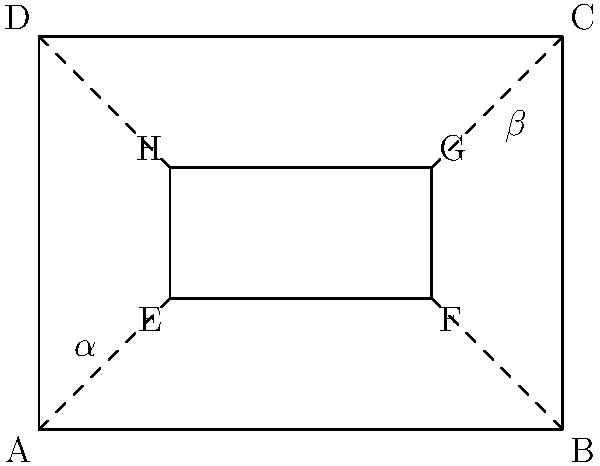In designing a stage set for your upcoming Broadway revival, you've created a rectangular backdrop (ABCD) with a smaller rectangular opening (EFGH) for a window. If angle $\alpha$ (formed by AE and AB) is congruent to angle $\beta$ (formed by CG and CB), what can you conclude about the shape EFGH in relation to ABCD? Let's approach this step-by-step:

1) In a rectangle, all interior angles are 90°. This applies to both ABCD and EFGH.

2) When a line is drawn from a corner of the larger rectangle to a corner of the smaller rectangle (like AE or CG), it creates two angles: one with the side of the larger rectangle and one with the side of the smaller rectangle.

3) We're told that angle $\alpha$ (formed by AE and AB) is congruent to angle $\beta$ (formed by CG and CB).

4) In a rectangle, opposite angles are congruent. So, the angle formed by AE and AD is congruent to angle $\beta$, and the angle formed by CG and CD is congruent to angle $\alpha$.

5) When a smaller rectangle is placed inside a larger rectangle in such a way that the angles formed by connecting their corners are congruent, it means the smaller rectangle is similar to the larger one and their sides are parallel.

6) This configuration is known as a "similarity transformation" or a "dilation" of the original rectangle.

Therefore, if angles $\alpha$ and $\beta$ are congruent, EFGH must be similar to ABCD and their sides must be parallel.
Answer: EFGH is similar to and parallel with ABCD. 